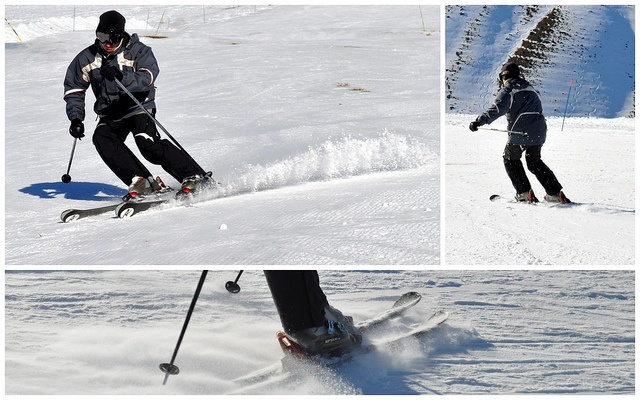Describe the objects in this image and their specific colors. I can see people in white, black, gray, and lightgray tones, people in white, black, gray, and darkgray tones, skis in white, darkgray, lightgray, gray, and black tones, people in white, black, gray, and darkblue tones, and skis in white, lightgray, gray, black, and darkgray tones in this image. 